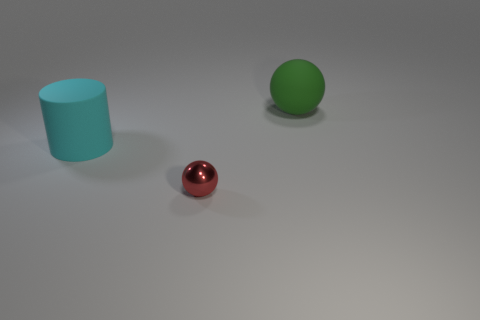Add 1 small brown metal cylinders. How many objects exist? 4 Subtract all balls. How many objects are left? 1 Subtract all green objects. Subtract all rubber objects. How many objects are left? 0 Add 2 cyan cylinders. How many cyan cylinders are left? 3 Add 2 red metallic things. How many red metallic things exist? 3 Subtract 0 purple cylinders. How many objects are left? 3 